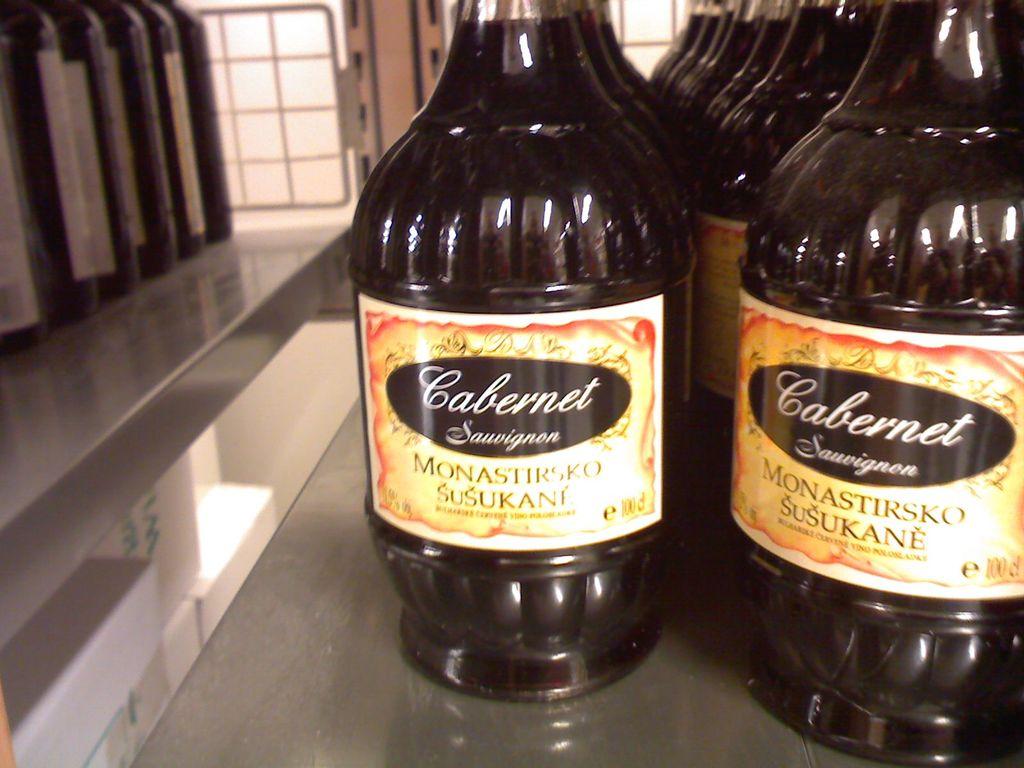What kind of wine is this?
Your response must be concise. Cabernet. What´s the brand of this wine?
Your answer should be very brief. Cabernet. 